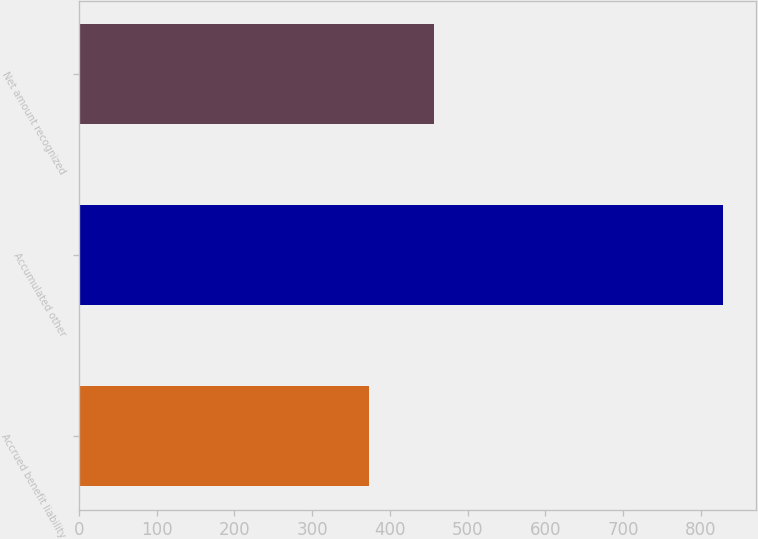<chart> <loc_0><loc_0><loc_500><loc_500><bar_chart><fcel>Accrued benefit liability<fcel>Accumulated other<fcel>Net amount recognized<nl><fcel>373<fcel>829<fcel>456<nl></chart> 